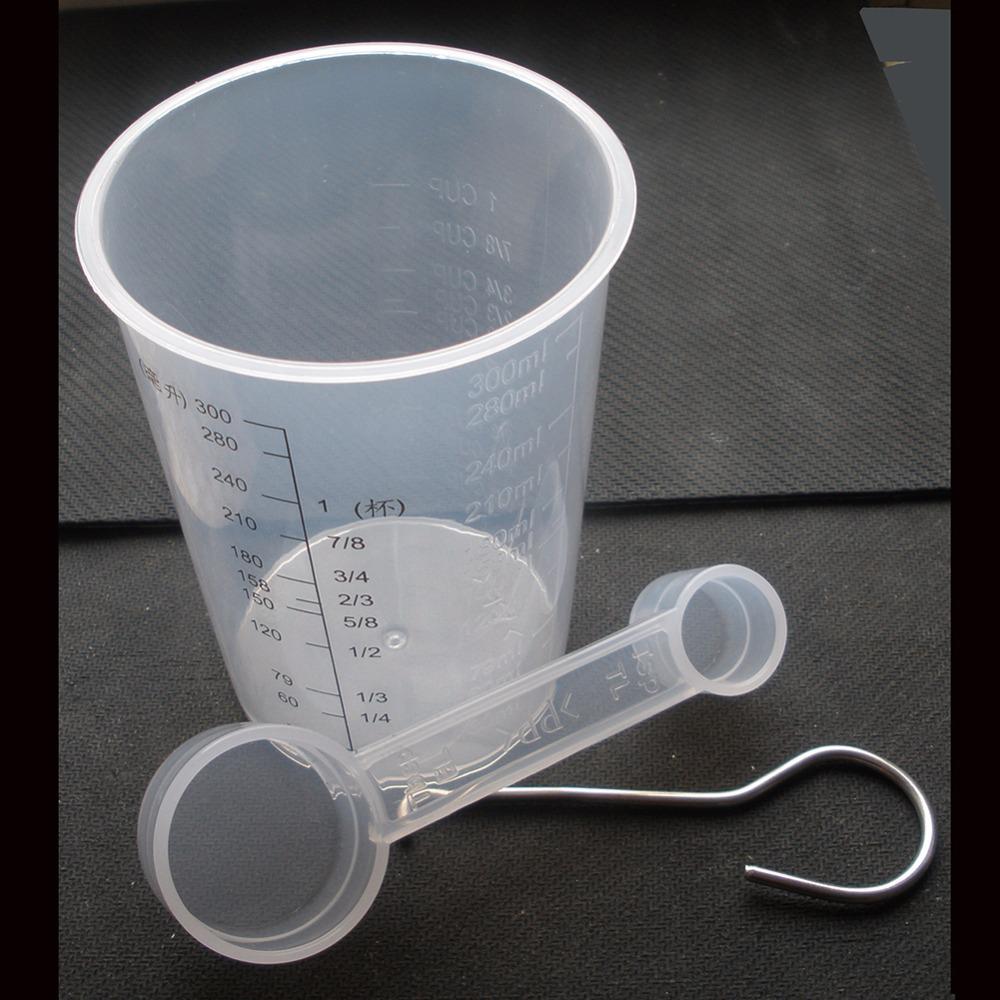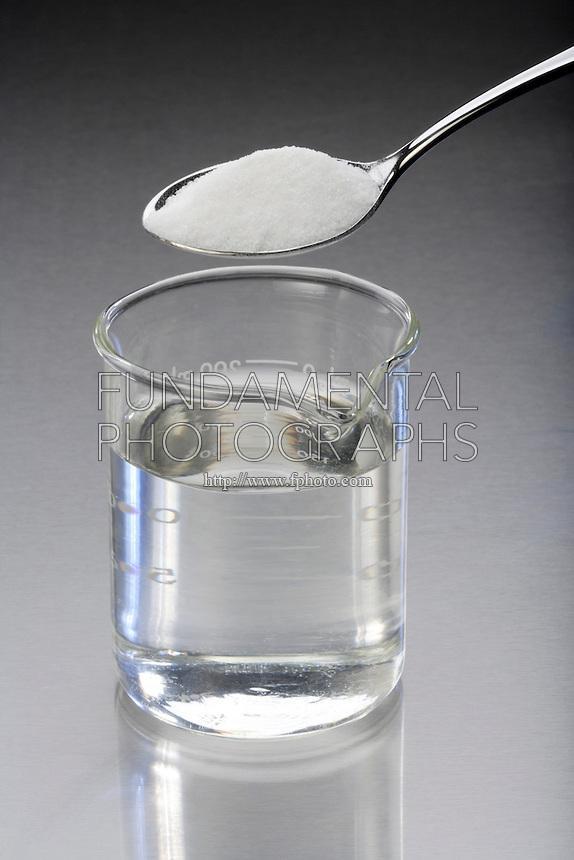The first image is the image on the left, the second image is the image on the right. Given the left and right images, does the statement "One of the images contains exactly five measuring cups." hold true? Answer yes or no. No. 